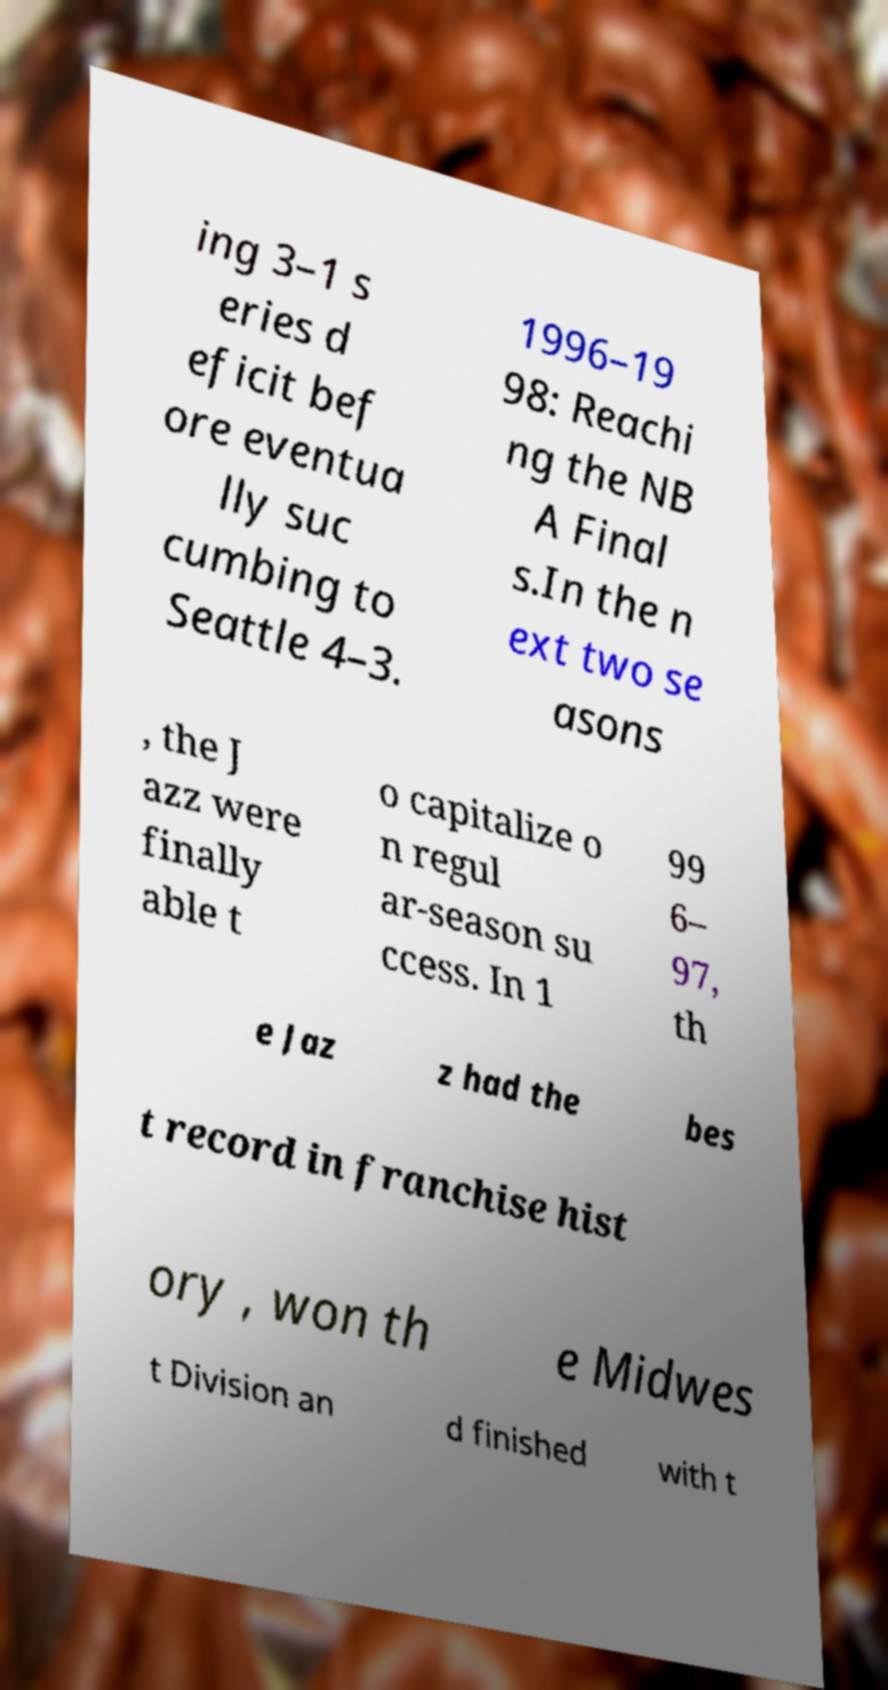Can you read and provide the text displayed in the image?This photo seems to have some interesting text. Can you extract and type it out for me? ing 3–1 s eries d eficit bef ore eventua lly suc cumbing to Seattle 4–3. 1996–19 98: Reachi ng the NB A Final s.In the n ext two se asons , the J azz were finally able t o capitalize o n regul ar-season su ccess. In 1 99 6– 97, th e Jaz z had the bes t record in franchise hist ory , won th e Midwes t Division an d finished with t 